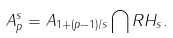Convert formula to latex. <formula><loc_0><loc_0><loc_500><loc_500>A _ { p } ^ { s } = A _ { 1 + ( p - 1 ) / s } \bigcap R H _ { s } .</formula> 